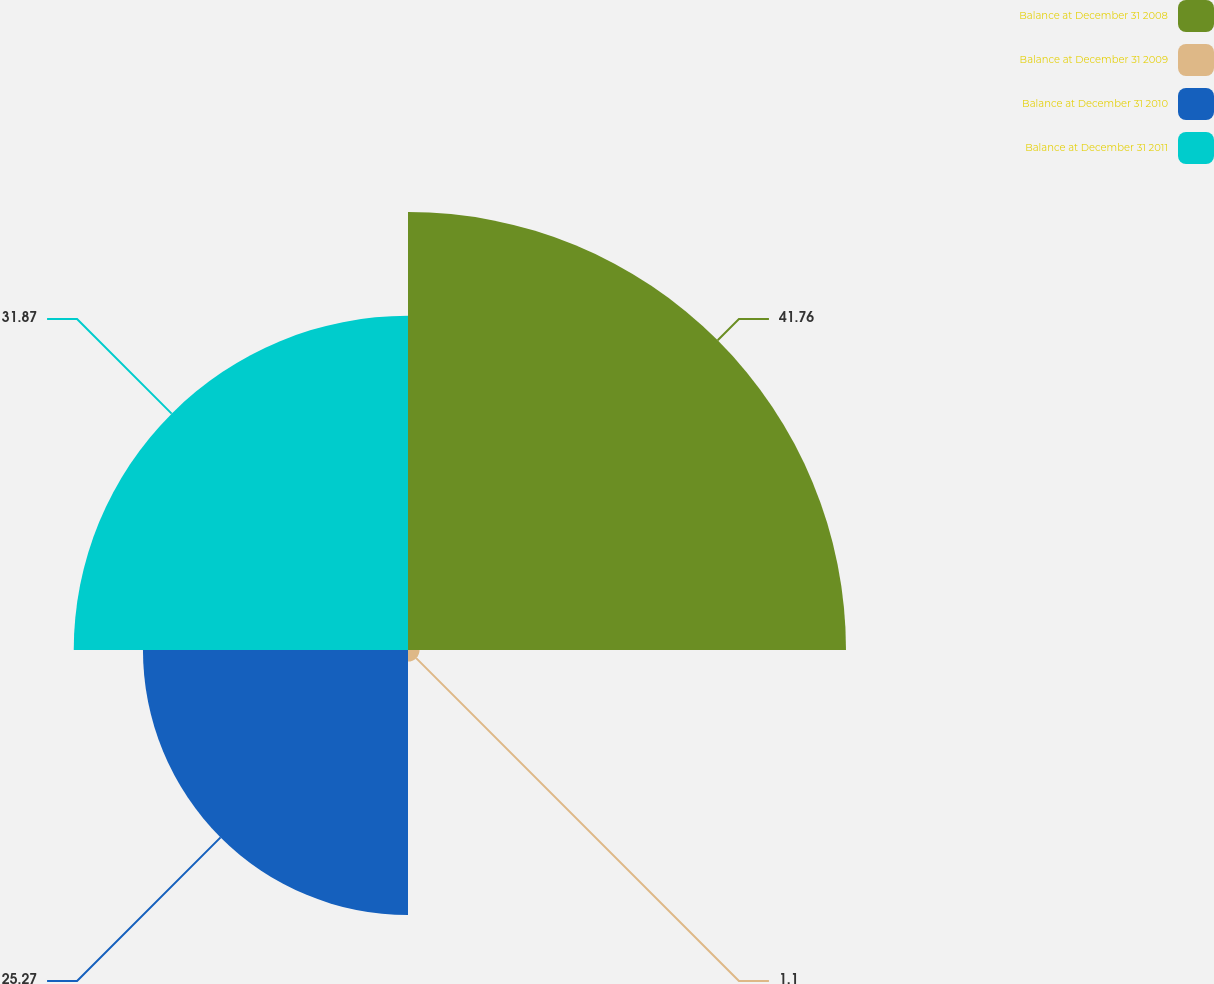Convert chart. <chart><loc_0><loc_0><loc_500><loc_500><pie_chart><fcel>Balance at December 31 2008<fcel>Balance at December 31 2009<fcel>Balance at December 31 2010<fcel>Balance at December 31 2011<nl><fcel>41.76%<fcel>1.1%<fcel>25.27%<fcel>31.87%<nl></chart> 